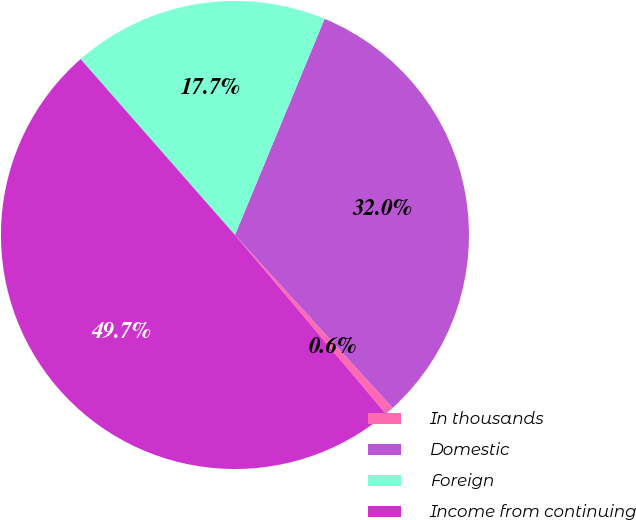<chart> <loc_0><loc_0><loc_500><loc_500><pie_chart><fcel>In thousands<fcel>Domestic<fcel>Foreign<fcel>Income from continuing<nl><fcel>0.61%<fcel>31.98%<fcel>17.72%<fcel>49.69%<nl></chart> 